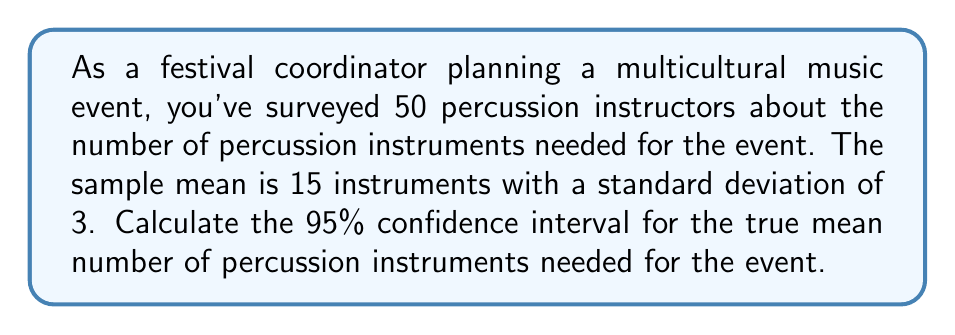Can you solve this math problem? To calculate the confidence interval, we'll use the formula:

$$ \text{CI} = \bar{x} \pm t_{\alpha/2, n-1} \cdot \frac{s}{\sqrt{n}} $$

Where:
$\bar{x}$ = sample mean = 15
$s$ = sample standard deviation = 3
$n$ = sample size = 50
$t_{\alpha/2, n-1}$ = t-value for 95% confidence level with 49 degrees of freedom

Steps:
1) Find $t_{\alpha/2, n-1}$:
   For 95% confidence and 49 df, $t_{0.025, 49} \approx 2.01$ (from t-table)

2) Calculate standard error:
   $SE = \frac{s}{\sqrt{n}} = \frac{3}{\sqrt{50}} = 0.4243$

3) Calculate margin of error:
   $ME = t_{\alpha/2, n-1} \cdot SE = 2.01 \cdot 0.4243 = 0.8528$

4) Calculate confidence interval:
   $\text{CI} = 15 \pm 0.8528$
   
   Lower bound: $15 - 0.8528 = 14.1472$
   Upper bound: $15 + 0.8528 = 15.8528$

Therefore, the 95% confidence interval is (14.15, 15.85).
Answer: (14.15, 15.85) 